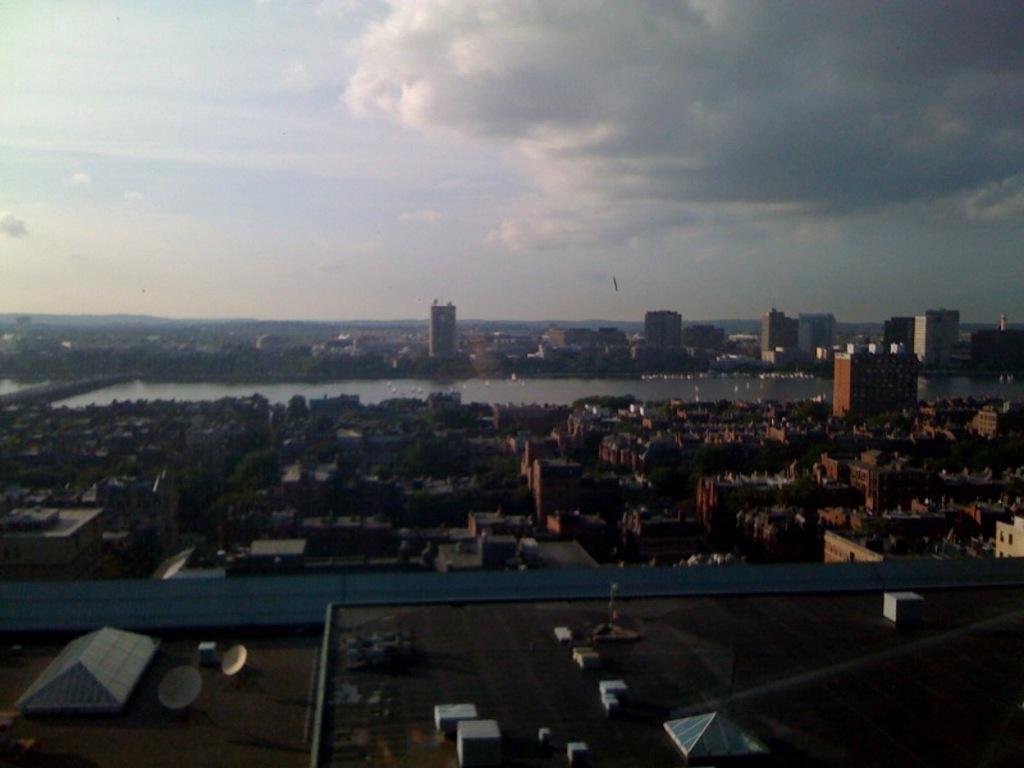Can you describe this image briefly? In this picture we can see satellite dishes and objects on the roof top. We can see buildings, trees and water. In the background of the image we can see sky with clouds. 